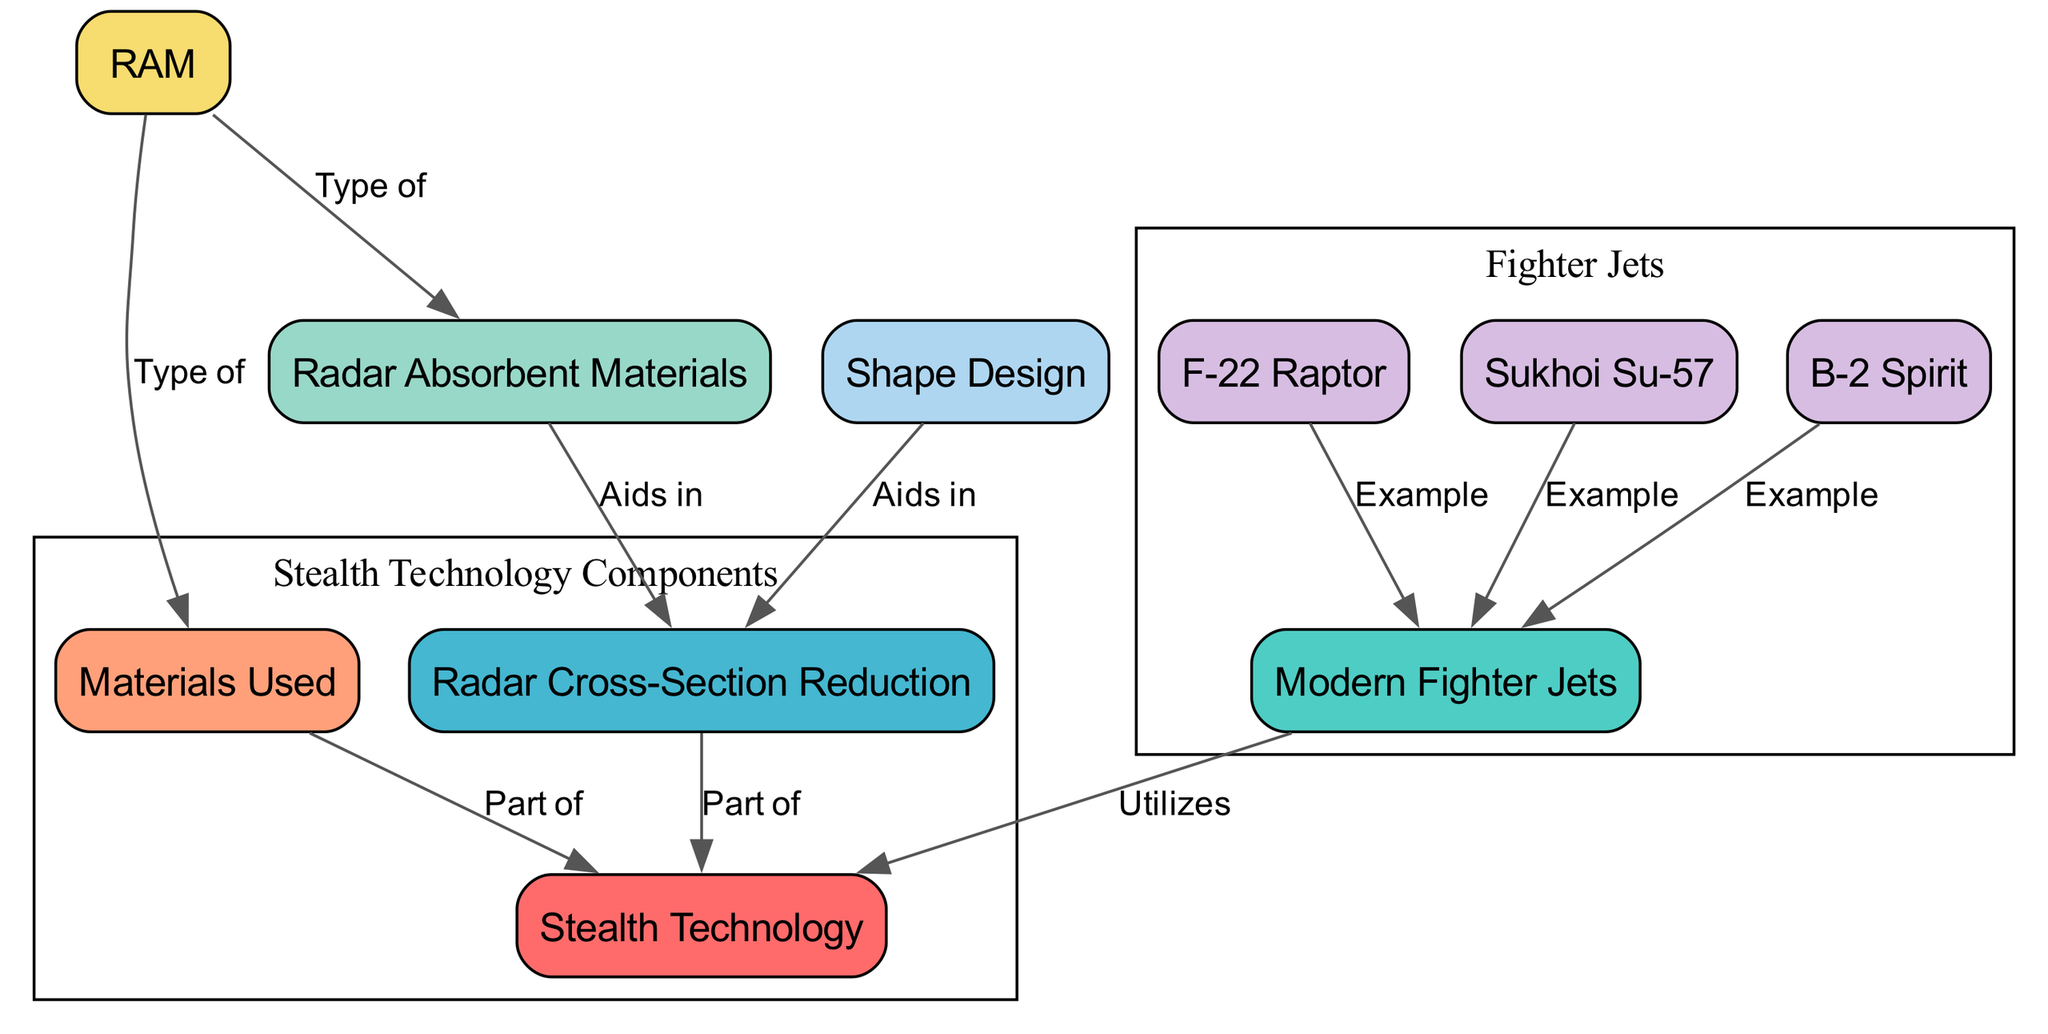What is the number of nodes in the diagram? The diagram includes several components, which can be counted by listing all distinct labeled nodes. There are 10 unique nodes present in the diagram.
Answer: 10 Which fighter jet is an example of modern fighter jets in the diagram? The diagram presents three specific examples of modern fighter jets: F-22 Raptor, Sukhoi Su-57, and B-2 Spirit. Any of these could be considered a correct answer, but F-22 Raptor is listed first.
Answer: F-22 Raptor What aids in reducing radar cross-section? In the diagram, the connections indicate that both absorbent materials and shape design contribute to radar cross-section reduction. Thus, either of these can be seen as a correct answer.
Answer: Absorbent materials Which type of material is a specific kind of radar absorbent material? The diagram indicates that RAM is a type of radar absorbent material. By tracing the connections in the diagram, it's clear that RAM directly relates to absorbent materials.
Answer: RAM How many examples of modern fighter jets are listed in the diagram? To determine the number, we look for the connections that denote fighter jets and count the provided instances. There are three examples listed: F-22 Raptor, Sukhoi Su-57, and B-2 Spirit.
Answer: 3 What part of stealth technology does radar cross-section reduction belong to? According to the relationships shown in the diagram, radar cross-section reduction is shown as a part of stealth technology. Thus, the answer can be directly obtained from its linkage.
Answer: Part of How does shape design relate to radar cross-section? The diagram shows that shape design aids in reducing the radar cross-section. By observing the directed edge leading from shape design to radar cross-section, we can confirm this relationship clearly.
Answer: Aids in Which type of material is part of stealth technology? In the diagram, we see that materials are identified as a component of stealth technology, making it directly identifiable.
Answer: Materials Which modern fighter jet is associated with stealth technology? The diagram illustrates that the connection between modern fighter jets and stealth technology includes the F-22 Raptor, Sukhoi Su-57, and B-2 Spirit, with any one of these being a valid answer.
Answer: Sukhoi Su-57 